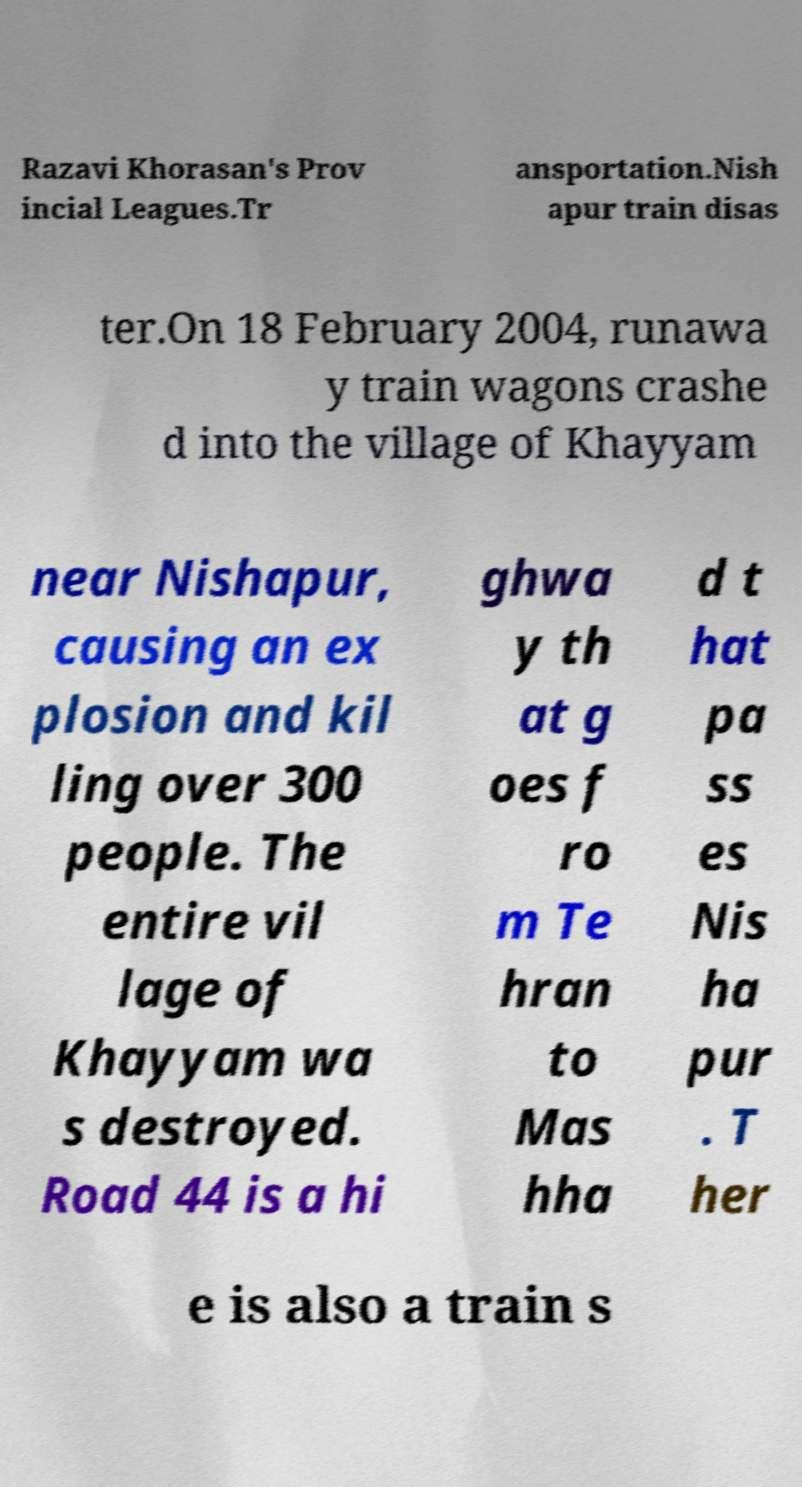What messages or text are displayed in this image? I need them in a readable, typed format. Razavi Khorasan's Prov incial Leagues.Tr ansportation.Nish apur train disas ter.On 18 February 2004, runawa y train wagons crashe d into the village of Khayyam near Nishapur, causing an ex plosion and kil ling over 300 people. The entire vil lage of Khayyam wa s destroyed. Road 44 is a hi ghwa y th at g oes f ro m Te hran to Mas hha d t hat pa ss es Nis ha pur . T her e is also a train s 